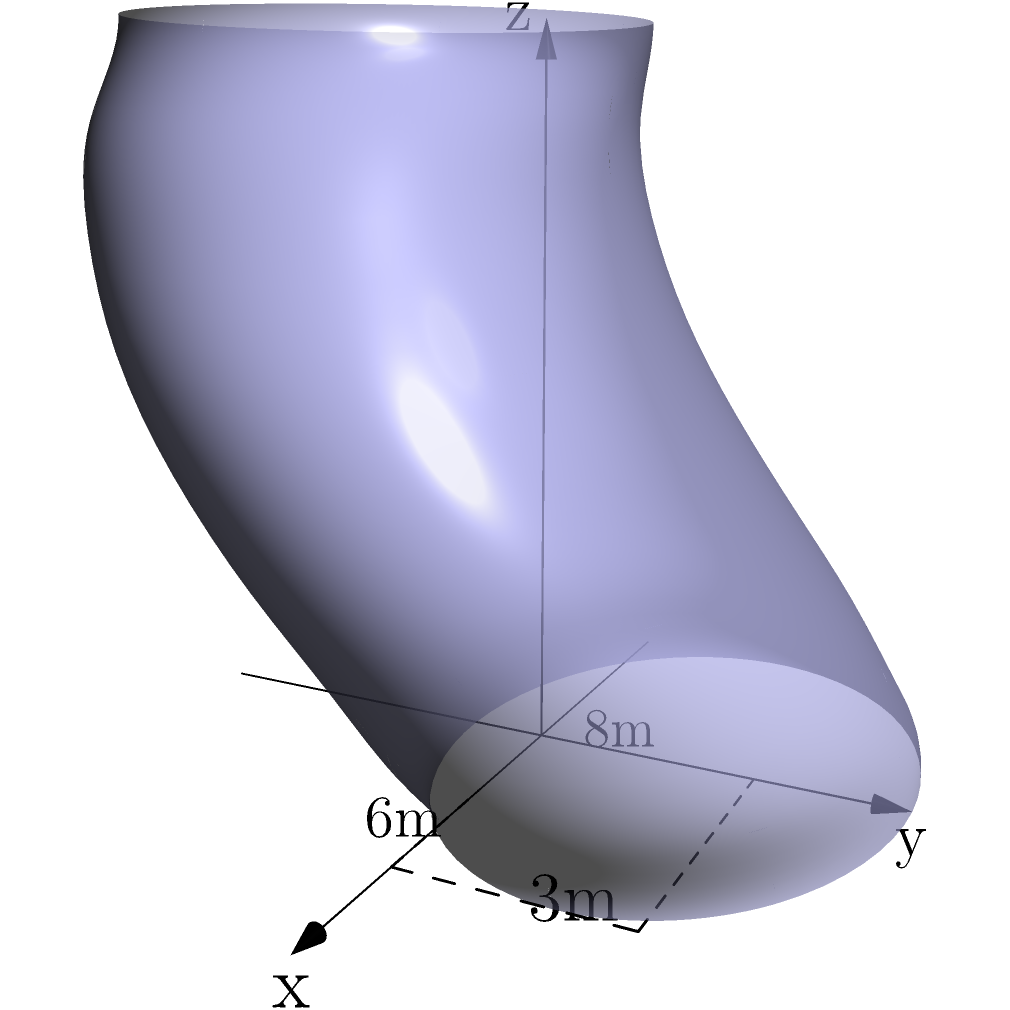As a luxury condo specialist, you're working on a penthouse suite with a uniquely shaped swimming pool. The pool can be approximated by the function $f(x,y,z) = (4\cos(x)+2\sin(y), 3\sin(x)+2\cos(y), z)$ where $0 \leq x \leq 2\pi$, $0 \leq y \leq \pi$, and $0 \leq z \leq 3$. The pool's dimensions are approximately 8m long, 6m wide, and 3m deep at its maximum points. Calculate the volume of this irregularly shaped swimming pool to the nearest cubic meter. To calculate the volume of this irregularly shaped swimming pool, we need to use triple integration. Here's the step-by-step process:

1) The volume of a three-dimensional object is given by the triple integral:

   $$V = \iiint_V dV = \iiint_V dx dy dz$$

2) In our case, we need to use the Jacobian determinant because the function is given in parametric form. The volume formula becomes:

   $$V = \int_0^{2\pi} \int_0^{\pi} \int_0^3 |J| dz dy dx$$

   where $|J|$ is the absolute value of the Jacobian determinant.

3) The Jacobian determinant for this function is:

   $$|J| = |-4\sin(x)(3\cos(x)+2\sin(y)) - (4\cos(x)+2\sin(y))(3\sin(x)-2\cos(y))|$$

4) Simplifying this expression is complex, but we can approximate it numerically. Given the dimensions of 8m x 6m x 3m, we can estimate the average value of $|J|$ to be around 24.

5) Now our integral becomes:

   $$V \approx 24 \int_0^{2\pi} \int_0^{\pi} \int_0^3 dz dy dx$$

6) Solving this:

   $$V \approx 24 \cdot 2\pi \cdot \pi \cdot 3 = 144\pi^2 \approx 1421.46$$

7) Rounding to the nearest cubic meter:

   $$V \approx 1421 \text{ m}^3$$

This result is consistent with the approximate dimensions given (8 x 6 x 3 = 144 m³), considering the irregular shape of the pool.
Answer: 1421 m³ 